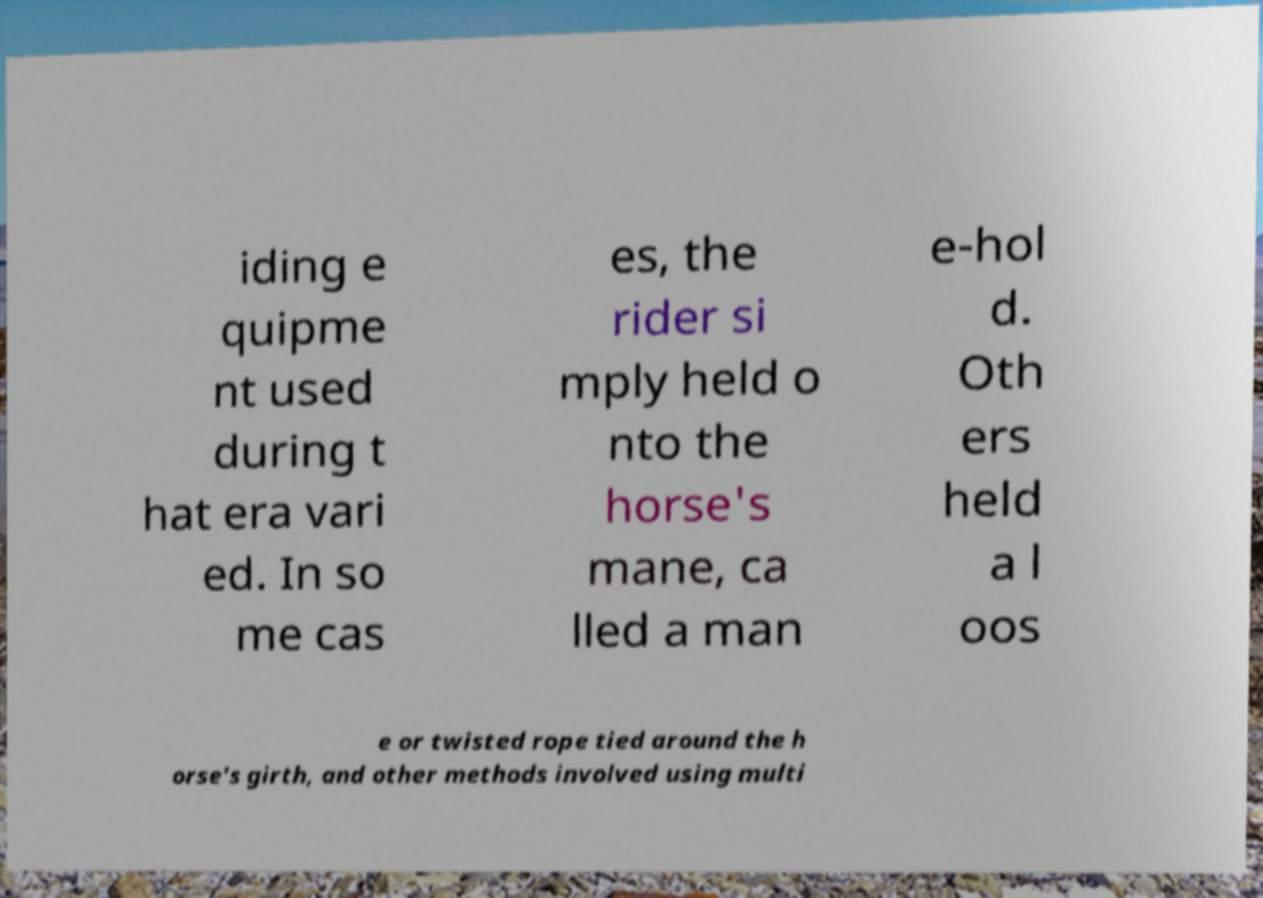Can you accurately transcribe the text from the provided image for me? iding e quipme nt used during t hat era vari ed. In so me cas es, the rider si mply held o nto the horse's mane, ca lled a man e-hol d. Oth ers held a l oos e or twisted rope tied around the h orse's girth, and other methods involved using multi 